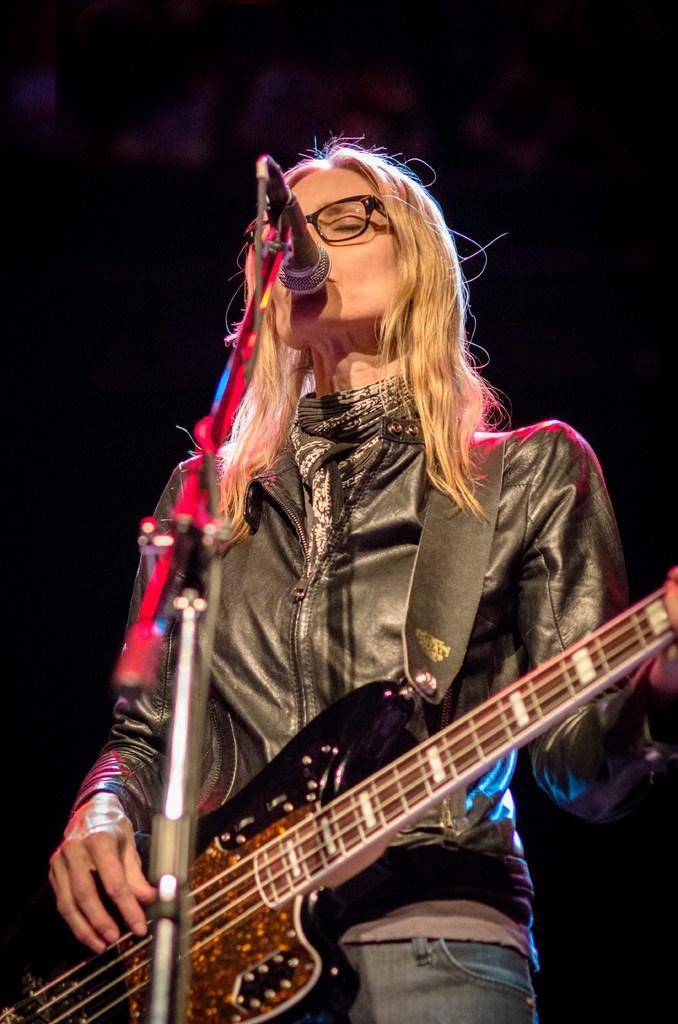Could you give a brief overview of what you see in this image? It is a music concert where a woman is wearing a black color jacket is also wearing a guitar around her, she is playing the guitar and also singing a song she is closing her eyes, the background is of black color. 